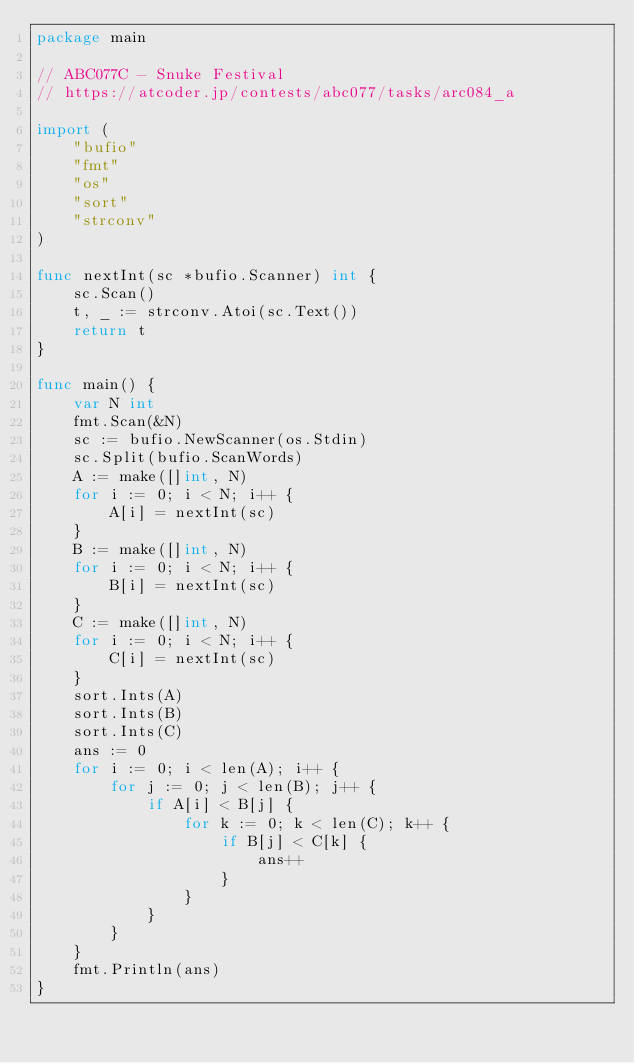Convert code to text. <code><loc_0><loc_0><loc_500><loc_500><_Go_>package main

// ABC077C - Snuke Festival
// https://atcoder.jp/contests/abc077/tasks/arc084_a

import (
	"bufio"
	"fmt"
	"os"
	"sort"
	"strconv"
)

func nextInt(sc *bufio.Scanner) int {
	sc.Scan()
	t, _ := strconv.Atoi(sc.Text())
	return t
}

func main() {
	var N int
	fmt.Scan(&N)
	sc := bufio.NewScanner(os.Stdin)
	sc.Split(bufio.ScanWords)
	A := make([]int, N)
	for i := 0; i < N; i++ {
		A[i] = nextInt(sc)
	}
	B := make([]int, N)
	for i := 0; i < N; i++ {
		B[i] = nextInt(sc)
	}
	C := make([]int, N)
	for i := 0; i < N; i++ {
		C[i] = nextInt(sc)
	}
	sort.Ints(A)
	sort.Ints(B)
	sort.Ints(C)
	ans := 0
	for i := 0; i < len(A); i++ {
		for j := 0; j < len(B); j++ {
			if A[i] < B[j] {
				for k := 0; k < len(C); k++ {
					if B[j] < C[k] {
						ans++
					}
				}
			}
		}
	}
	fmt.Println(ans)
}
</code> 